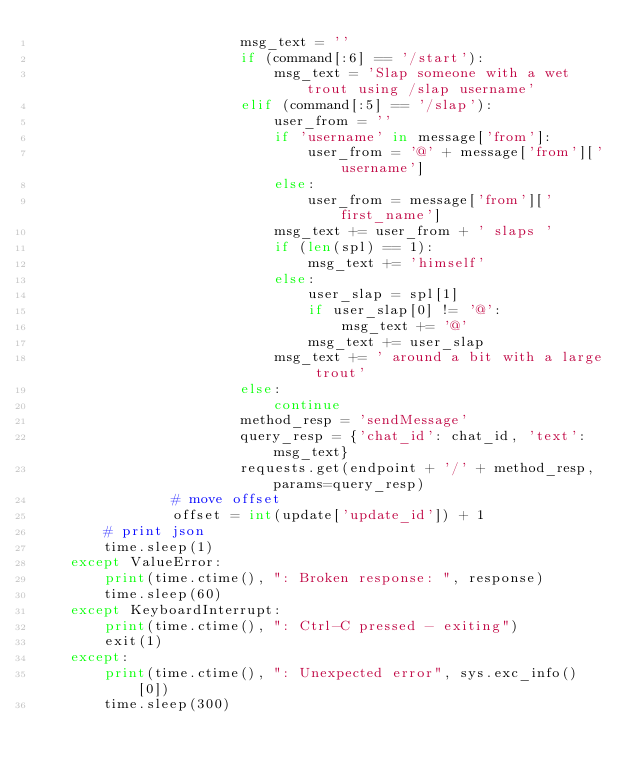Convert code to text. <code><loc_0><loc_0><loc_500><loc_500><_Python_>                        msg_text = ''
                        if (command[:6] == '/start'):
                            msg_text = 'Slap someone with a wet trout using /slap username'
                        elif (command[:5] == '/slap'):
                            user_from = ''
                            if 'username' in message['from']:
                                user_from = '@' + message['from']['username']
                            else:
                                user_from = message['from']['first_name']
                            msg_text += user_from + ' slaps '
                            if (len(spl) == 1):
                                msg_text += 'himself'
                            else:
                                user_slap = spl[1]
                                if user_slap[0] != '@':
                                    msg_text += '@'
                                msg_text += user_slap
                            msg_text += ' around a bit with a large trout'
                        else:
                            continue
                        method_resp = 'sendMessage'
                        query_resp = {'chat_id': chat_id, 'text': msg_text}
                        requests.get(endpoint + '/' + method_resp, params=query_resp)
                # move offset
                offset = int(update['update_id']) + 1
        # print json
        time.sleep(1)
    except ValueError:
        print(time.ctime(), ": Broken response: ", response)
        time.sleep(60)
    except KeyboardInterrupt:
        print(time.ctime(), ": Ctrl-C pressed - exiting")
        exit(1)
    except:
        print(time.ctime(), ": Unexpected error", sys.exc_info()[0])
        time.sleep(300)
</code> 